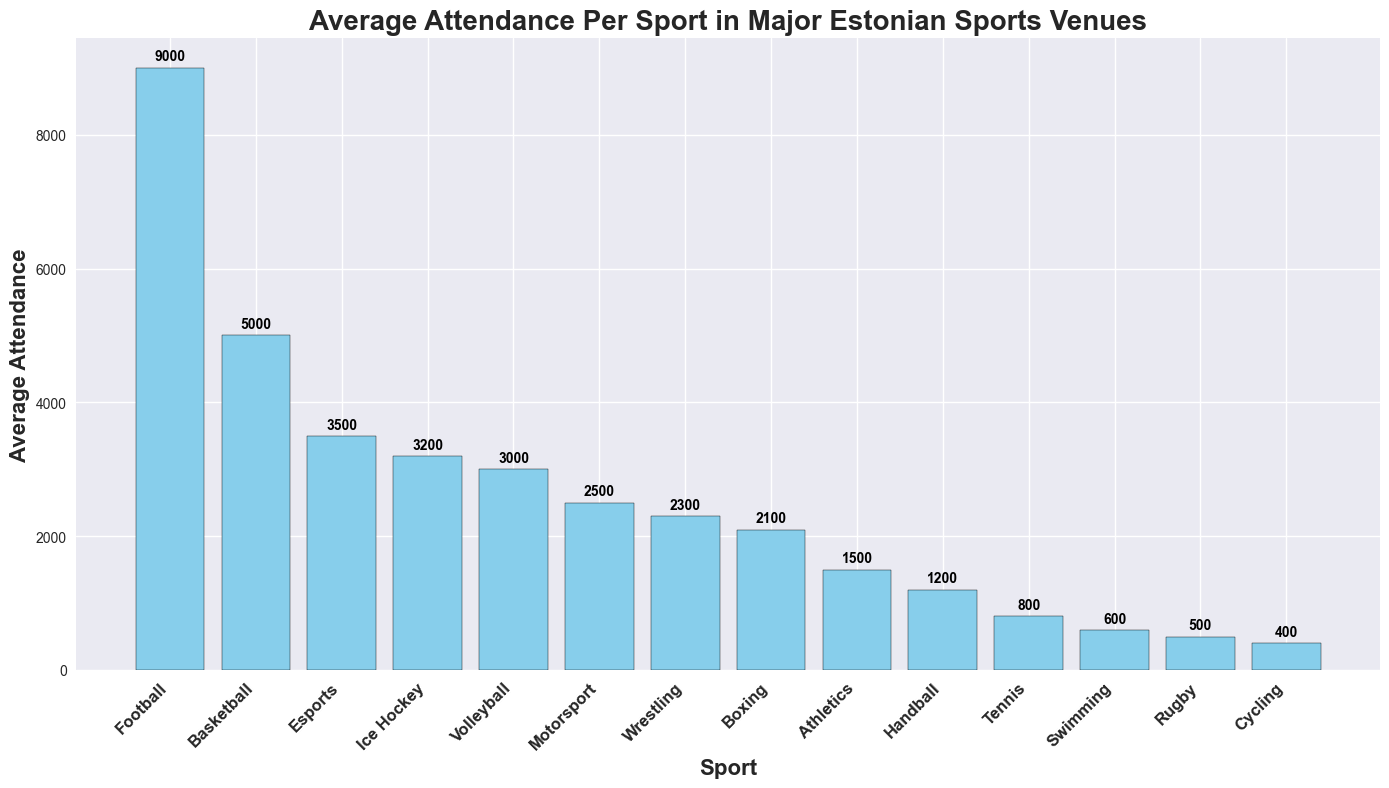how many people on average attend football matches at A. Le Coq Arena? Look at the bar for football and read the number above it.
Answer: 9000 which sport has the lowest average attendance, and what is the value? Identify the shortest bar in the chart, read the sport name, and the value above the bar.
Answer: Cycling, 400 calculate the total average attendance for all sports combined. Sum up the average attendance values for all sports: 9000 + 5000 + 3000 + 3200 + 1500 + 800 + 1200 + 500 + 600 + 400 + 2300 + 2100 + 3500 + 2500 = 36000
Answer: 36000 which sport hosted at Saku Suurhall has a higher average attendance, basketball or wrestling? Compare the heights of the bars for basketball and wrestling.
Answer: Basketball how much higher is the average attendance of football compared to swimming? Subtract the average attendance of swimming from the average attendance of football: 9000 - 600 = 8400
Answer: 8400 between ice hockey and volleyball, which sport has a higher average attendance and by how much? Compare the heights of the bars for ice hockey and volleyball, and find the difference: 3200 - 3000 = 200
Answer: Ice Hockey by 200 how many sports have an average attendance greater than 2000? Count the bars with values above 2000: Football, Basketball, Ice Hockey, Wrestling, Boxing, Esports, Motorsport. There are 7 sports.
Answer: 7 which venue hosts the most sports, and what are they? Check which venue name appears most frequently in the sport list and list the associated sports. Saku Suurhall hosts Basketball, Wrestling, and Boxing.
Answer: Saku Suurhall, Basketball, Wrestling, Boxing what is the average attendance for sports held in Kadriorg Stadium? Sum the average attendance for sports at Kadriorg Stadium: Athletics (1500) + Rugby (500) = 2000; then, divide by the number of sports: 2000 / 2 = 1000
Answer: 1000 is the average attendance for esports higher than the overall average attendance of all sports combined? Calculate the overall average attendance: 36000 / 14 = 2571. Check if 3500 is greater than 2571.
Answer: Yes 